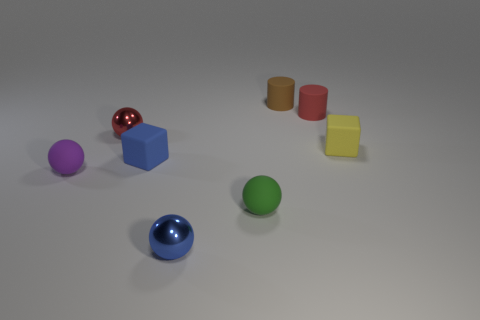Subtract all green cylinders. How many yellow blocks are left? 1 Subtract all small cylinders. Subtract all matte balls. How many objects are left? 4 Add 1 small brown cylinders. How many small brown cylinders are left? 2 Add 8 small green rubber objects. How many small green rubber objects exist? 9 Add 1 rubber blocks. How many objects exist? 9 Subtract all red cylinders. How many cylinders are left? 1 Subtract all purple balls. How many balls are left? 3 Subtract 0 cyan balls. How many objects are left? 8 Subtract 2 cylinders. How many cylinders are left? 0 Subtract all purple cylinders. Subtract all yellow spheres. How many cylinders are left? 2 